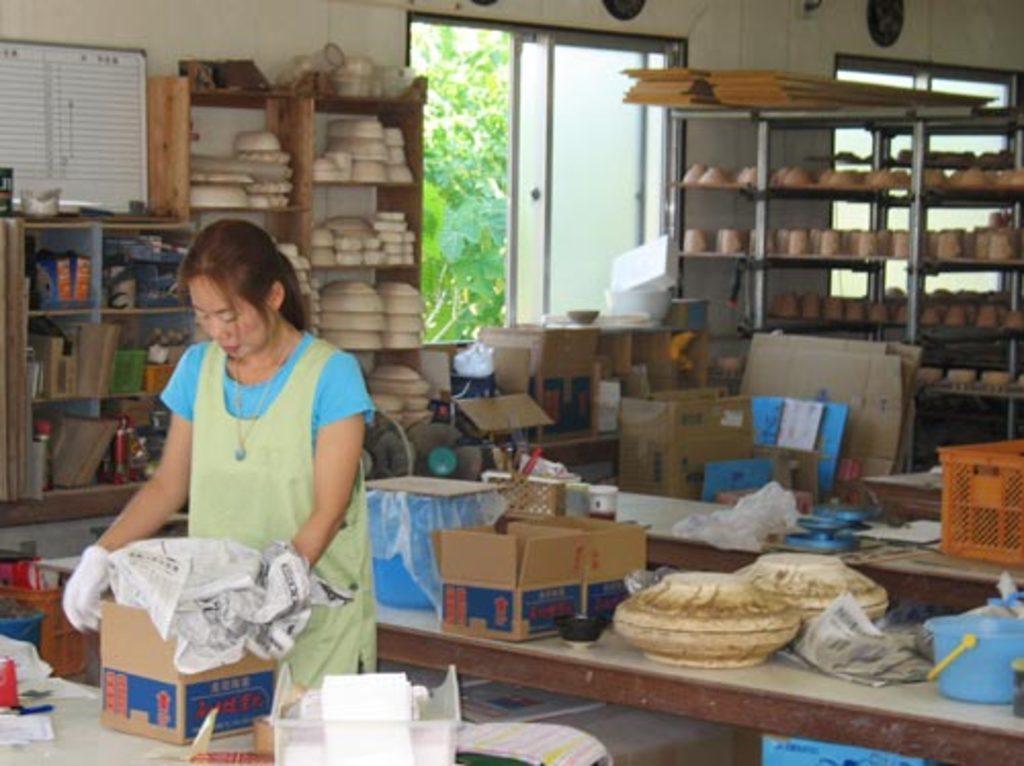Describe this image in one or two sentences. In this image on the left side there is one woman who is standing and she is holding some box, and in front of her there is a table. On the table there are some boxes, papers and some objects. In the background also there are some tables, on the tables i can see some boxes, baskets, bowls, papers and some other objects. And in the background there are some cupboards, and in the cupboards there are some bowls, books, and some objects. In the center there is a window and some plants, on the right side there is another window and on the left side there is one board. And at the bottom there is a floor and in the center there are some boxes and some bottles, bowls and some other objects. 